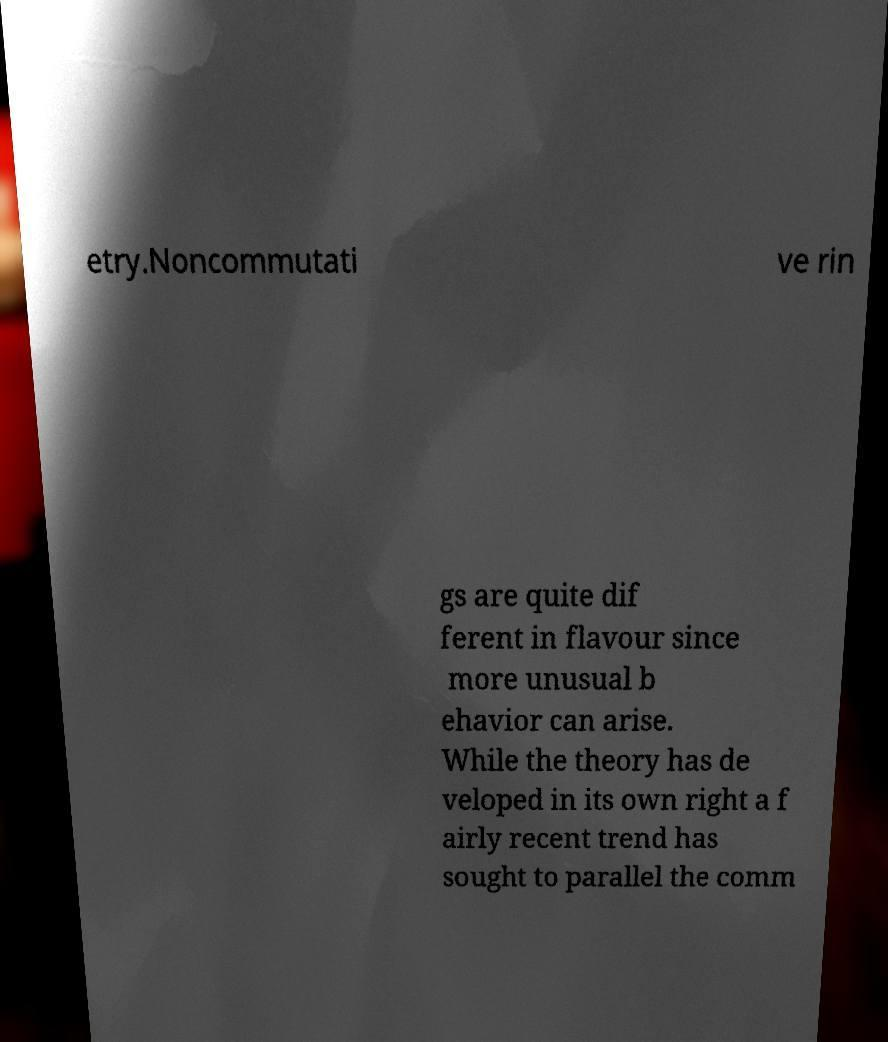Please read and relay the text visible in this image. What does it say? etry.Noncommutati ve rin gs are quite dif ferent in flavour since more unusual b ehavior can arise. While the theory has de veloped in its own right a f airly recent trend has sought to parallel the comm 